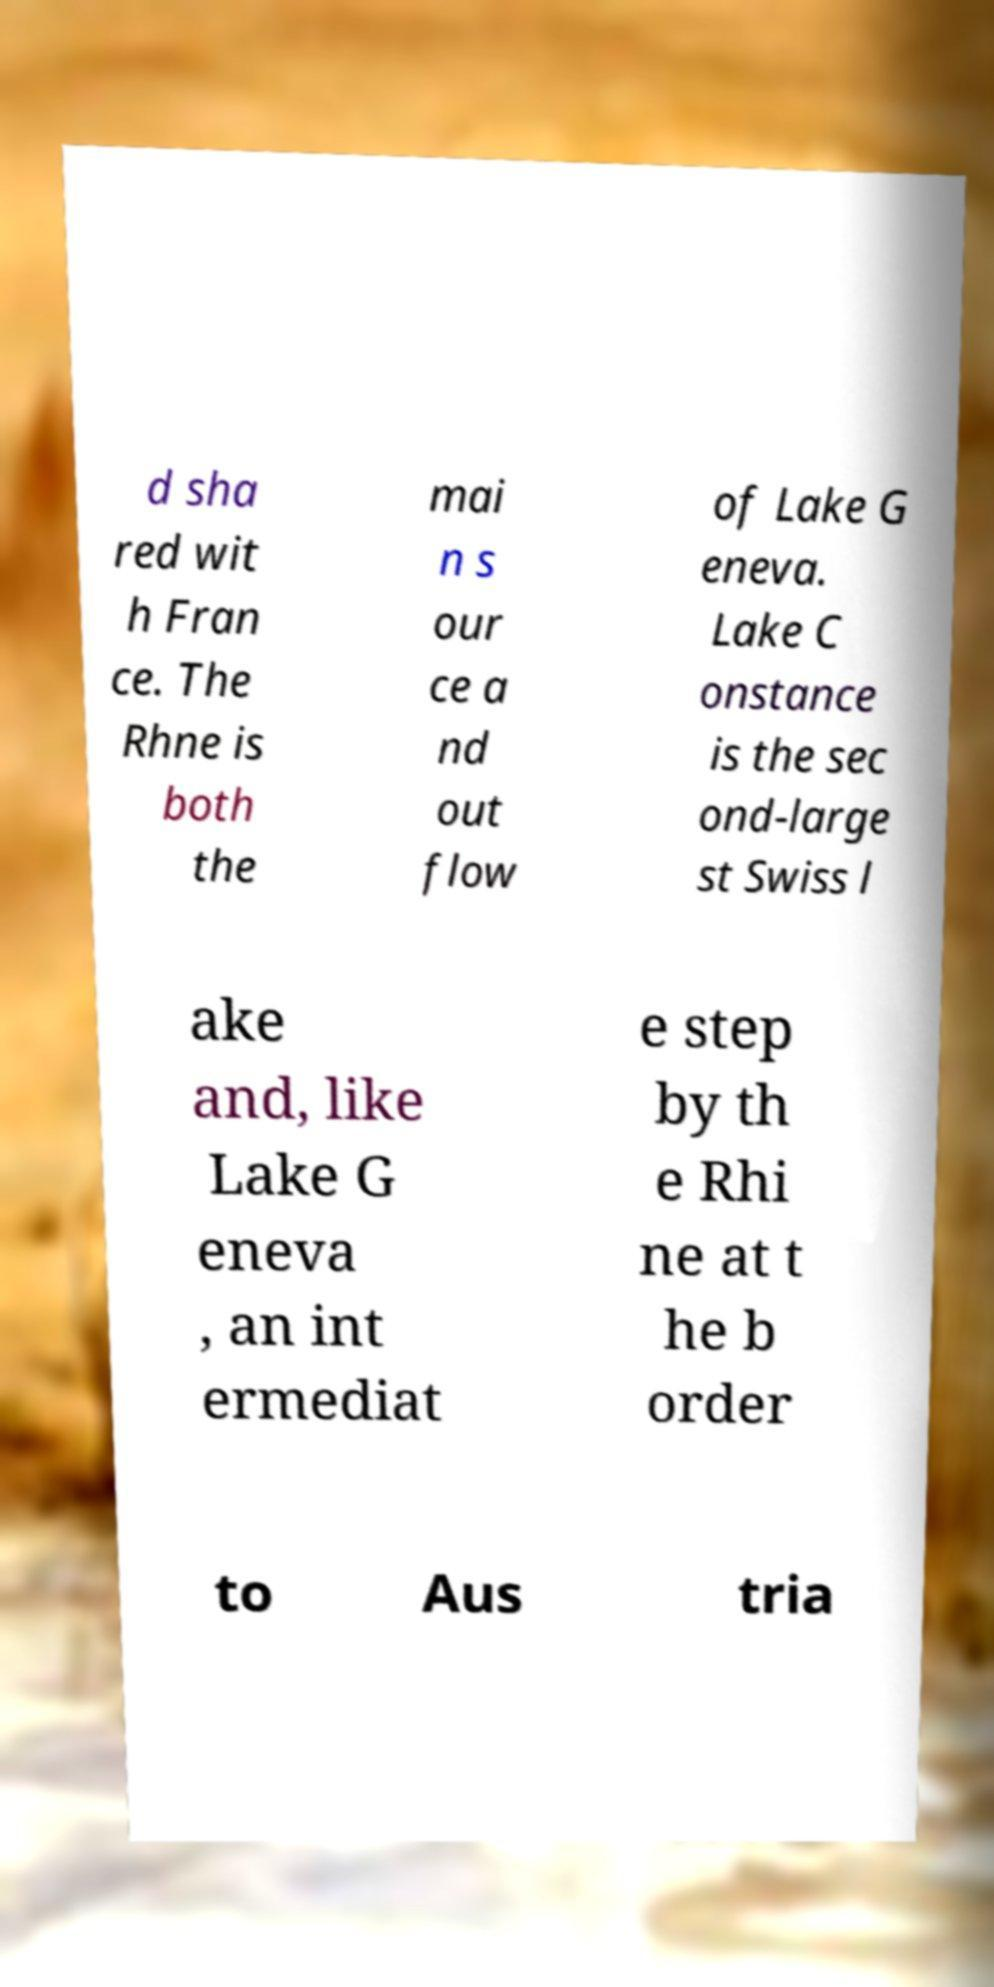Please read and relay the text visible in this image. What does it say? d sha red wit h Fran ce. The Rhne is both the mai n s our ce a nd out flow of Lake G eneva. Lake C onstance is the sec ond-large st Swiss l ake and, like Lake G eneva , an int ermediat e step by th e Rhi ne at t he b order to Aus tria 